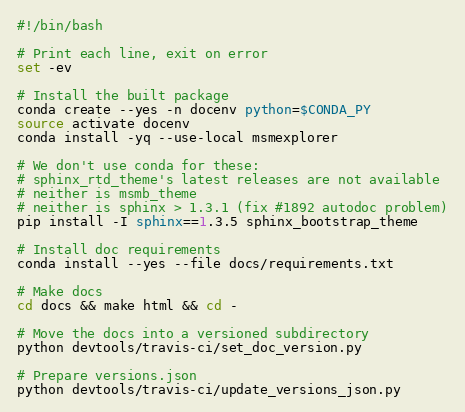<code> <loc_0><loc_0><loc_500><loc_500><_Bash_>#!/bin/bash

# Print each line, exit on error
set -ev

# Install the built package
conda create --yes -n docenv python=$CONDA_PY
source activate docenv
conda install -yq --use-local msmexplorer

# We don't use conda for these:
# sphinx_rtd_theme's latest releases are not available
# neither is msmb_theme
# neither is sphinx > 1.3.1 (fix #1892 autodoc problem)
pip install -I sphinx==1.3.5 sphinx_bootstrap_theme

# Install doc requirements
conda install --yes --file docs/requirements.txt

# Make docs
cd docs && make html && cd -

# Move the docs into a versioned subdirectory
python devtools/travis-ci/set_doc_version.py

# Prepare versions.json
python devtools/travis-ci/update_versions_json.py
</code> 